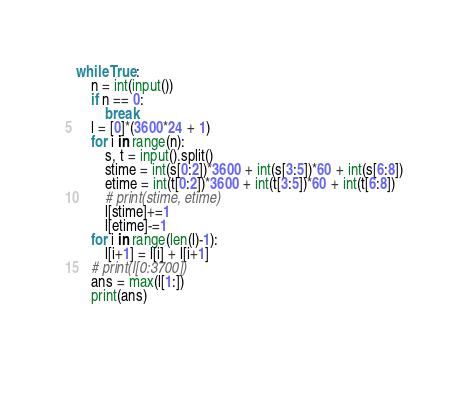<code> <loc_0><loc_0><loc_500><loc_500><_Python_>while True:
    n = int(input())
    if n == 0:
        break
    l = [0]*(3600*24 + 1)
    for i in range(n):
        s, t = input().split()
        stime = int(s[0:2])*3600 + int(s[3:5])*60 + int(s[6:8])
        etime = int(t[0:2])*3600 + int(t[3:5])*60 + int(t[6:8])
        # print(stime, etime)
        l[stime]+=1
        l[etime]-=1
    for i in range(len(l)-1):
        l[i+1] = l[i] + l[i+1]
    # print(l[0:3700])
    ans = max(l[1:])
    print(ans)    

    
</code> 